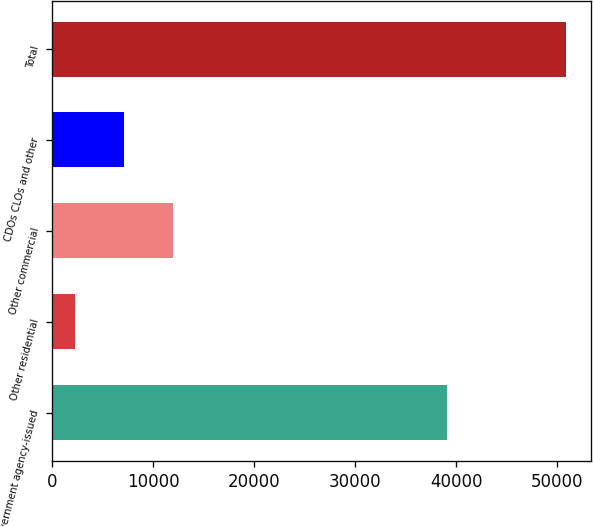<chart> <loc_0><loc_0><loc_500><loc_500><bar_chart><fcel>US government agency-issued<fcel>Other residential<fcel>Other commercial<fcel>CDOs CLOs and other<fcel>Total<nl><fcel>39088<fcel>2195<fcel>11927.4<fcel>7061.2<fcel>50857<nl></chart> 